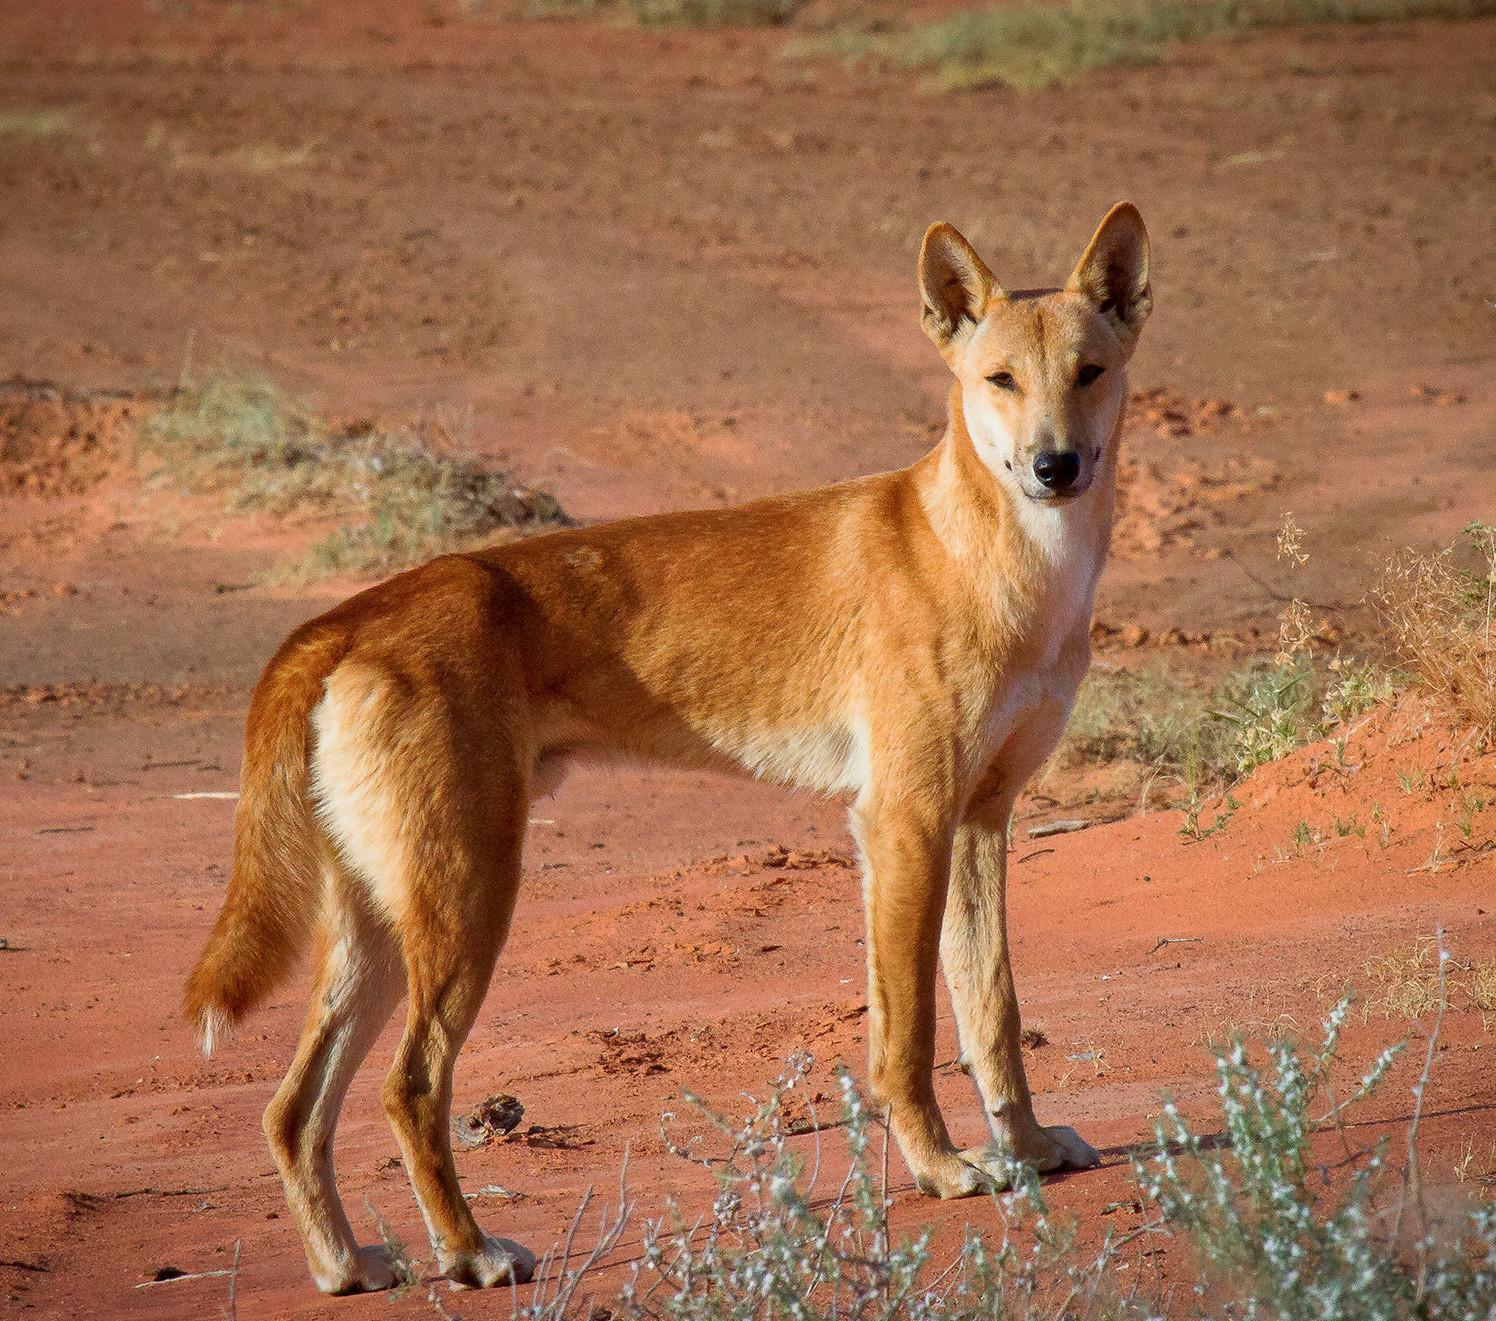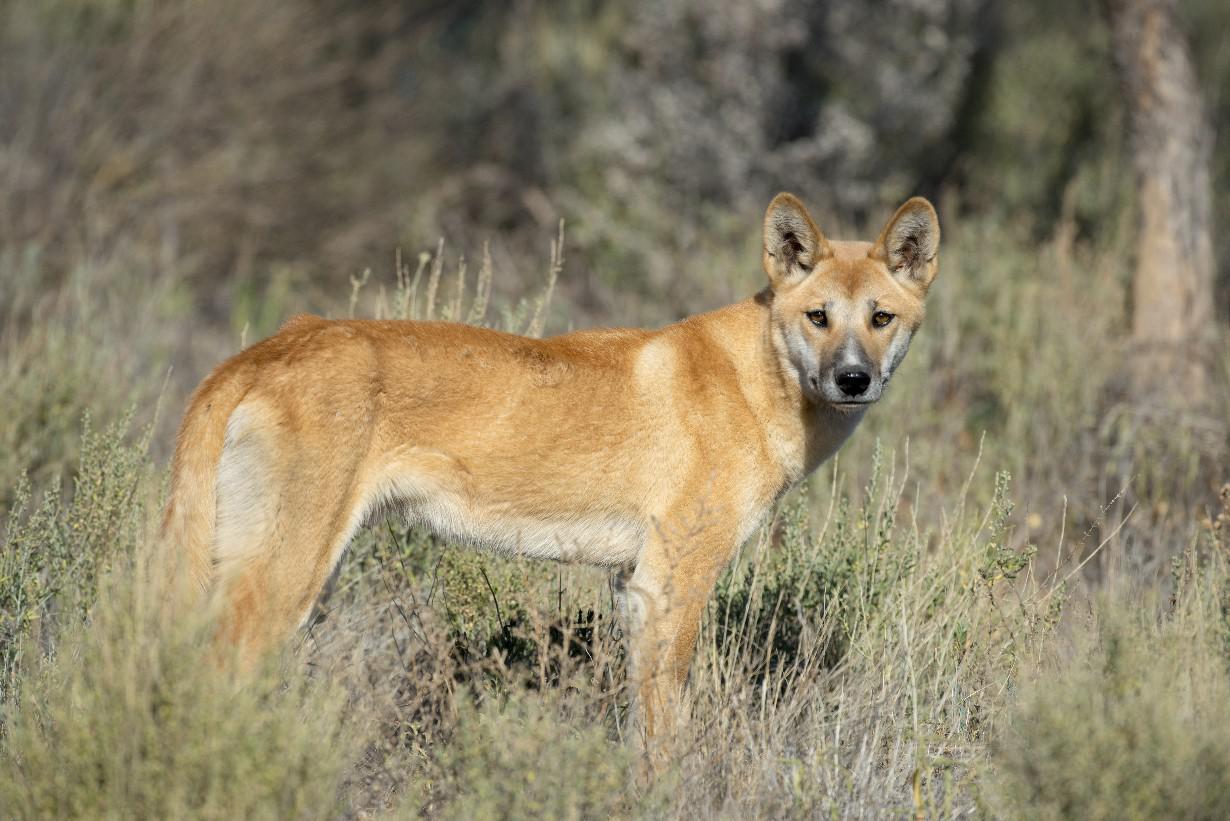The first image is the image on the left, the second image is the image on the right. Examine the images to the left and right. Is the description "there is a canine lying down in the image to the left" accurate? Answer yes or no. No. The first image is the image on the left, the second image is the image on the right. Considering the images on both sides, is "The left image features a dingo reclining with upright head, and all dingos shown are adults." valid? Answer yes or no. No. 